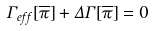<formula> <loc_0><loc_0><loc_500><loc_500>\Gamma _ { e f f } [ \overline { \pi } ] + \Delta \Gamma [ \overline { \pi } ] = 0</formula> 